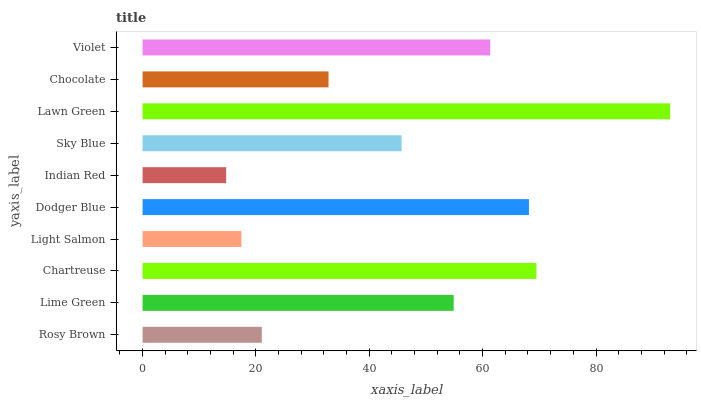Is Indian Red the minimum?
Answer yes or no. Yes. Is Lawn Green the maximum?
Answer yes or no. Yes. Is Lime Green the minimum?
Answer yes or no. No. Is Lime Green the maximum?
Answer yes or no. No. Is Lime Green greater than Rosy Brown?
Answer yes or no. Yes. Is Rosy Brown less than Lime Green?
Answer yes or no. Yes. Is Rosy Brown greater than Lime Green?
Answer yes or no. No. Is Lime Green less than Rosy Brown?
Answer yes or no. No. Is Lime Green the high median?
Answer yes or no. Yes. Is Sky Blue the low median?
Answer yes or no. Yes. Is Chartreuse the high median?
Answer yes or no. No. Is Rosy Brown the low median?
Answer yes or no. No. 